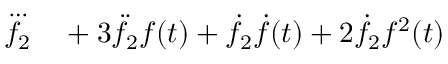<formula> <loc_0><loc_0><loc_500><loc_500>\begin{array} { r l } { \dddot { f _ { 2 } } } & + 3 \ddot { f } _ { 2 } f ( t ) + \dot { f } _ { 2 } \dot { f } ( t ) + 2 \dot { f } _ { 2 } f ^ { 2 } ( t ) } \end{array}</formula> 